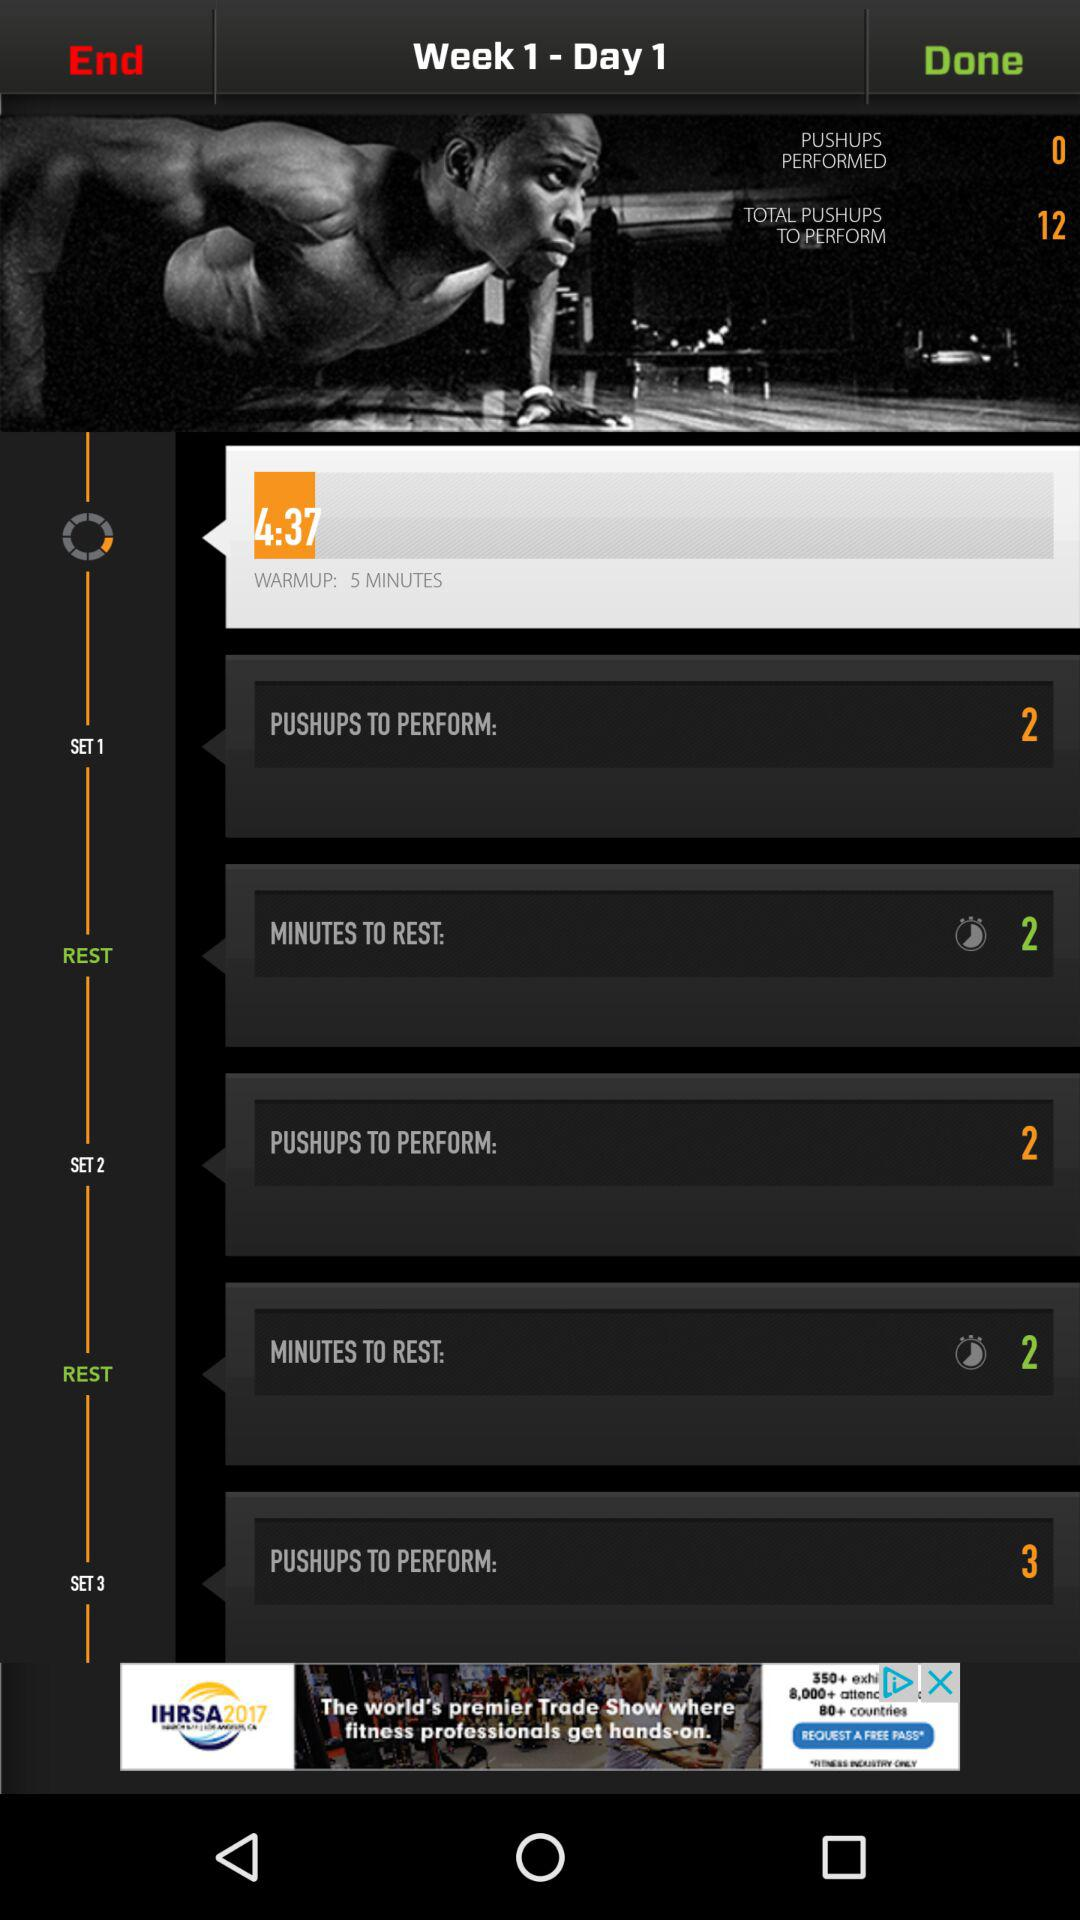What exercise week is it? It is the first week of exercise. 